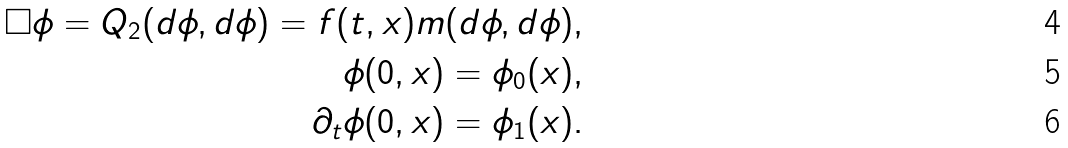Convert formula to latex. <formula><loc_0><loc_0><loc_500><loc_500>\Box \phi = Q _ { 2 } ( d \phi , d \phi ) = f ( t , x ) m ( d \phi , d \phi ) , \\ \phi ( 0 , x ) = \phi _ { 0 } ( x ) , \\ \partial _ { t } \phi ( 0 , x ) = \phi _ { 1 } ( x ) .</formula> 